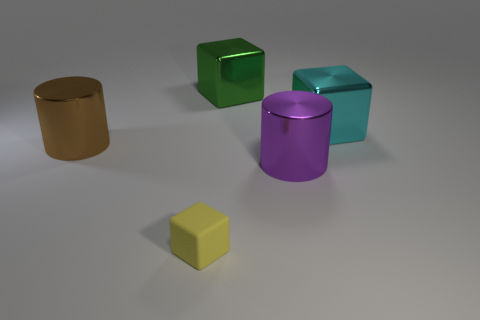The object that is on the left side of the block that is in front of the cyan metallic cube is made of what material?
Offer a very short reply. Metal. Is the material of the large object to the left of the tiny yellow thing the same as the yellow thing?
Offer a terse response. No. Is there a green block behind the large metallic cylinder to the right of the tiny yellow cube?
Offer a very short reply. Yes. The tiny matte cube has what color?
Give a very brief answer. Yellow. Is there anything else of the same color as the small rubber object?
Ensure brevity in your answer.  No. There is a large object that is both left of the big purple metal cylinder and in front of the green metal thing; what color is it?
Provide a short and direct response. Brown. There is a metal cylinder on the right side of the yellow block; is its size the same as the large cyan block?
Make the answer very short. Yes. Is the number of metallic things that are left of the tiny block greater than the number of red cylinders?
Give a very brief answer. Yes. Does the brown thing have the same shape as the big purple object?
Your answer should be compact. Yes. The purple shiny cylinder is what size?
Your answer should be very brief. Large. 